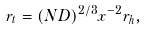<formula> <loc_0><loc_0><loc_500><loc_500>r _ { t } = ( N D ) ^ { 2 / 3 } x ^ { - 2 } r _ { h } ,</formula> 